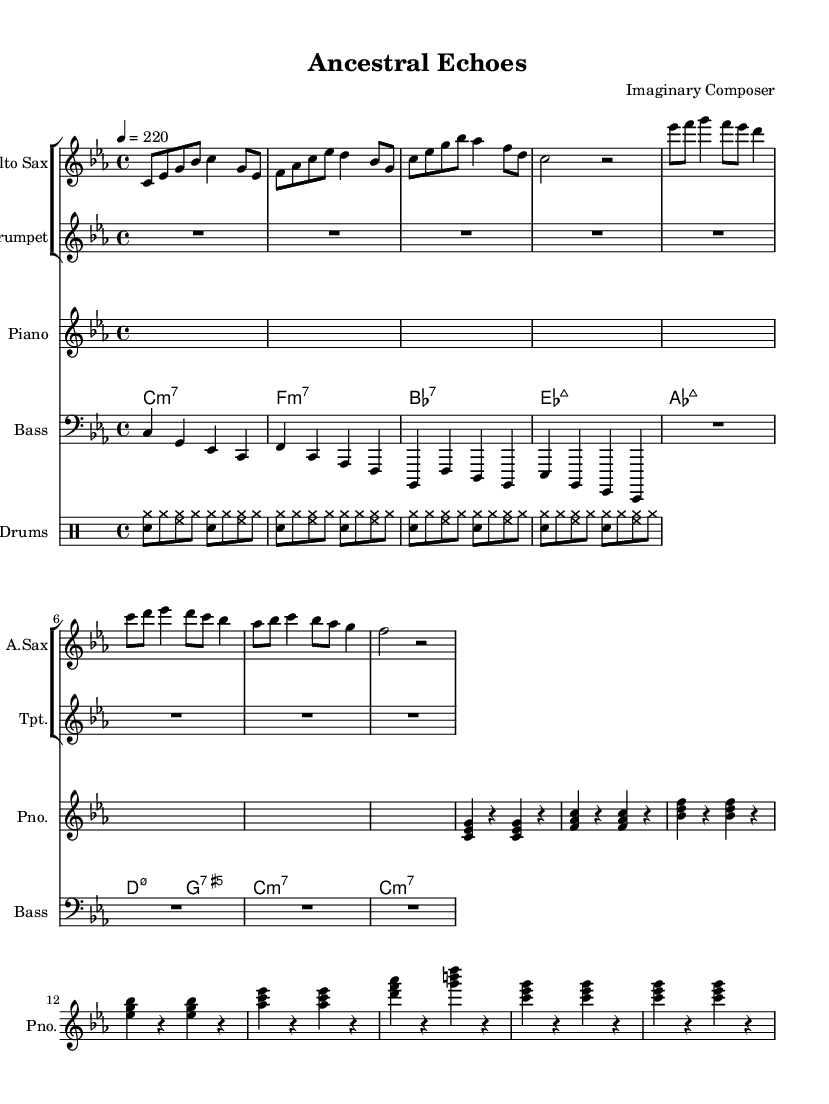What is the key signature of this music? The key signature is C minor, which has three flats (B flat, E flat, and A flat). You can identify this by looking for the flat symbols placed at the beginning of the staff for the staff in the key signature section.
Answer: C minor What is the time signature of this piece? The time signature is 4/4, which is indicated at the beginning of the music. This means there are four beats in each measure and the quarter note receives one beat.
Answer: 4/4 What is the tempo marking for this score? The tempo marking is 4 = 220. This indicates a fast tempo, with 220 beats per minute, suggesting an energetic and brisk pace typical in bebop music.
Answer: 220 How many measures are in the main theme? The main theme consists of 4 measures. Counting the measures in the alto sax part, you can see that it forms a coherent section ending before the B section begins.
Answer: 4 What instrument plays the main theme? The instrument playing the main theme is the alto saxophone, as indicated by the notation in that staff. The main themes are written under this staff.
Answer: Alto Sax What chords are used in the left hand of the piano? The chords used are C minor 7, F minor 7, B flat 7, E flat major 7, A flat major 7, D minor 7, G 7, and repeat C minor 7. Each chord is indicated at the beginning of the corresponding measure.
Answer: C minor 7, F minor 7, B flat 7, E flat major 7, A flat major 7, D minor 7, G 7 How often do the drums use the snare drum? The snare drum is used in every eighth note pattern in the drum part. You can see each grouping includes the snare drum played in conjunction with the hi-hat and bass, which indicates a consistent rhythm throughout.
Answer: Every measure 